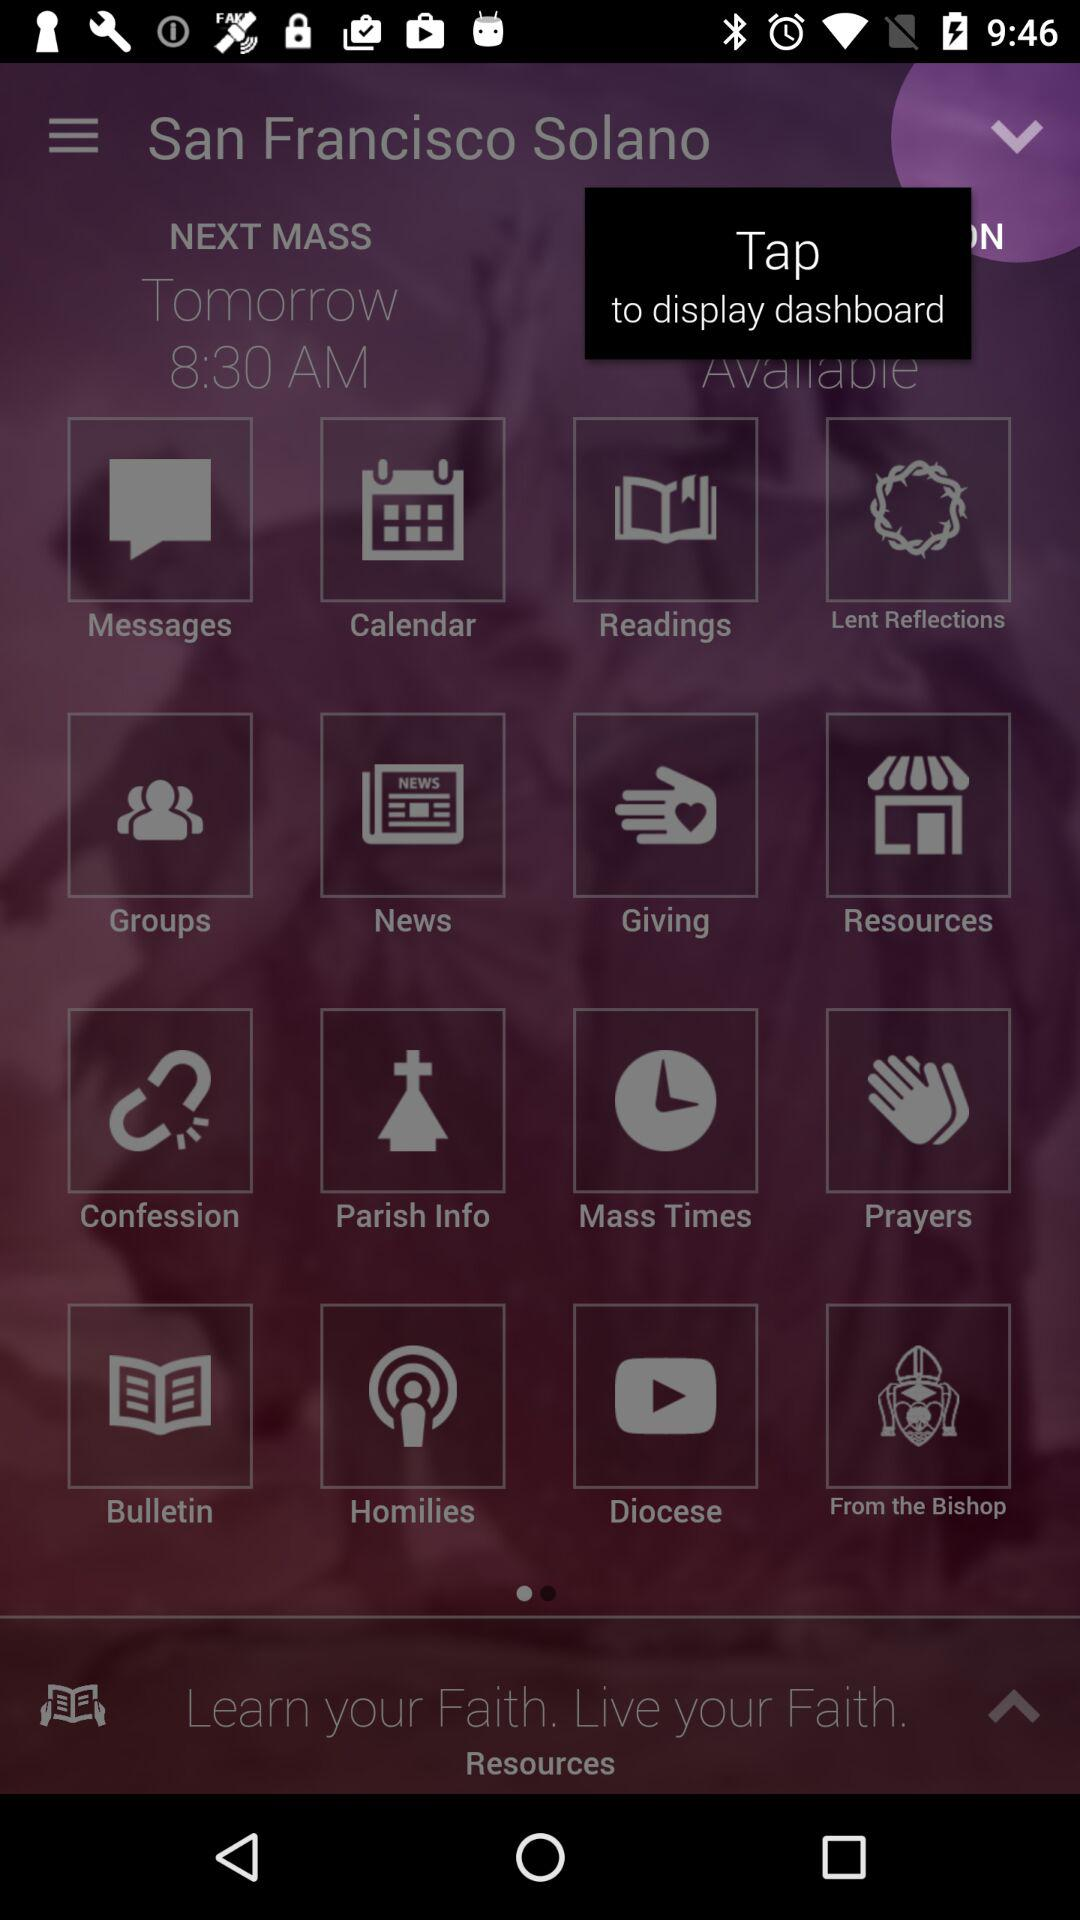What is the given timing for the next mass? The given timing is 8:30 AM. 